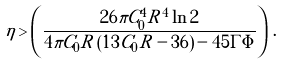Convert formula to latex. <formula><loc_0><loc_0><loc_500><loc_500>\eta > \left ( \frac { 2 6 \pi C _ { 0 } ^ { 4 } R ^ { 4 } \ln 2 } { 4 \pi C _ { 0 } R \left ( 1 3 C _ { 0 } R - 3 6 \right ) - 4 5 \Gamma \Phi } \right ) \, .</formula> 